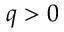<formula> <loc_0><loc_0><loc_500><loc_500>q > 0</formula> 